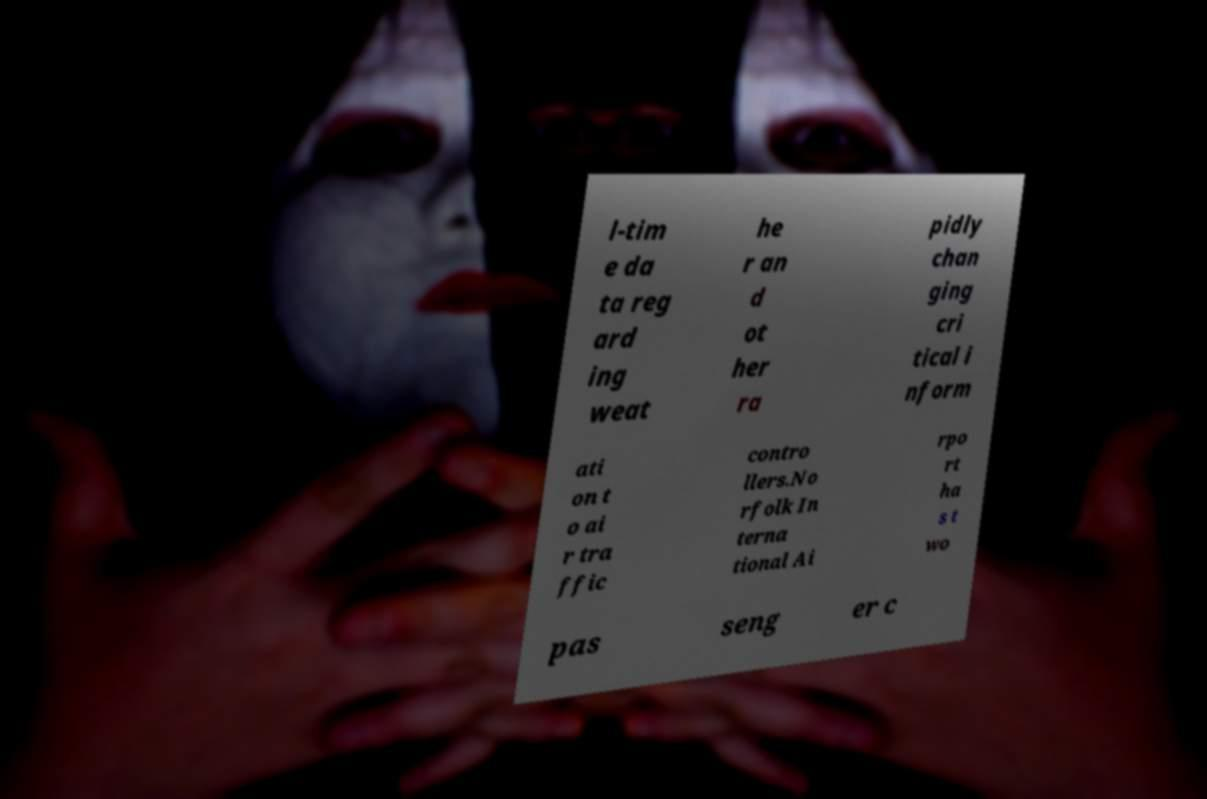Could you assist in decoding the text presented in this image and type it out clearly? l-tim e da ta reg ard ing weat he r an d ot her ra pidly chan ging cri tical i nform ati on t o ai r tra ffic contro llers.No rfolk In terna tional Ai rpo rt ha s t wo pas seng er c 